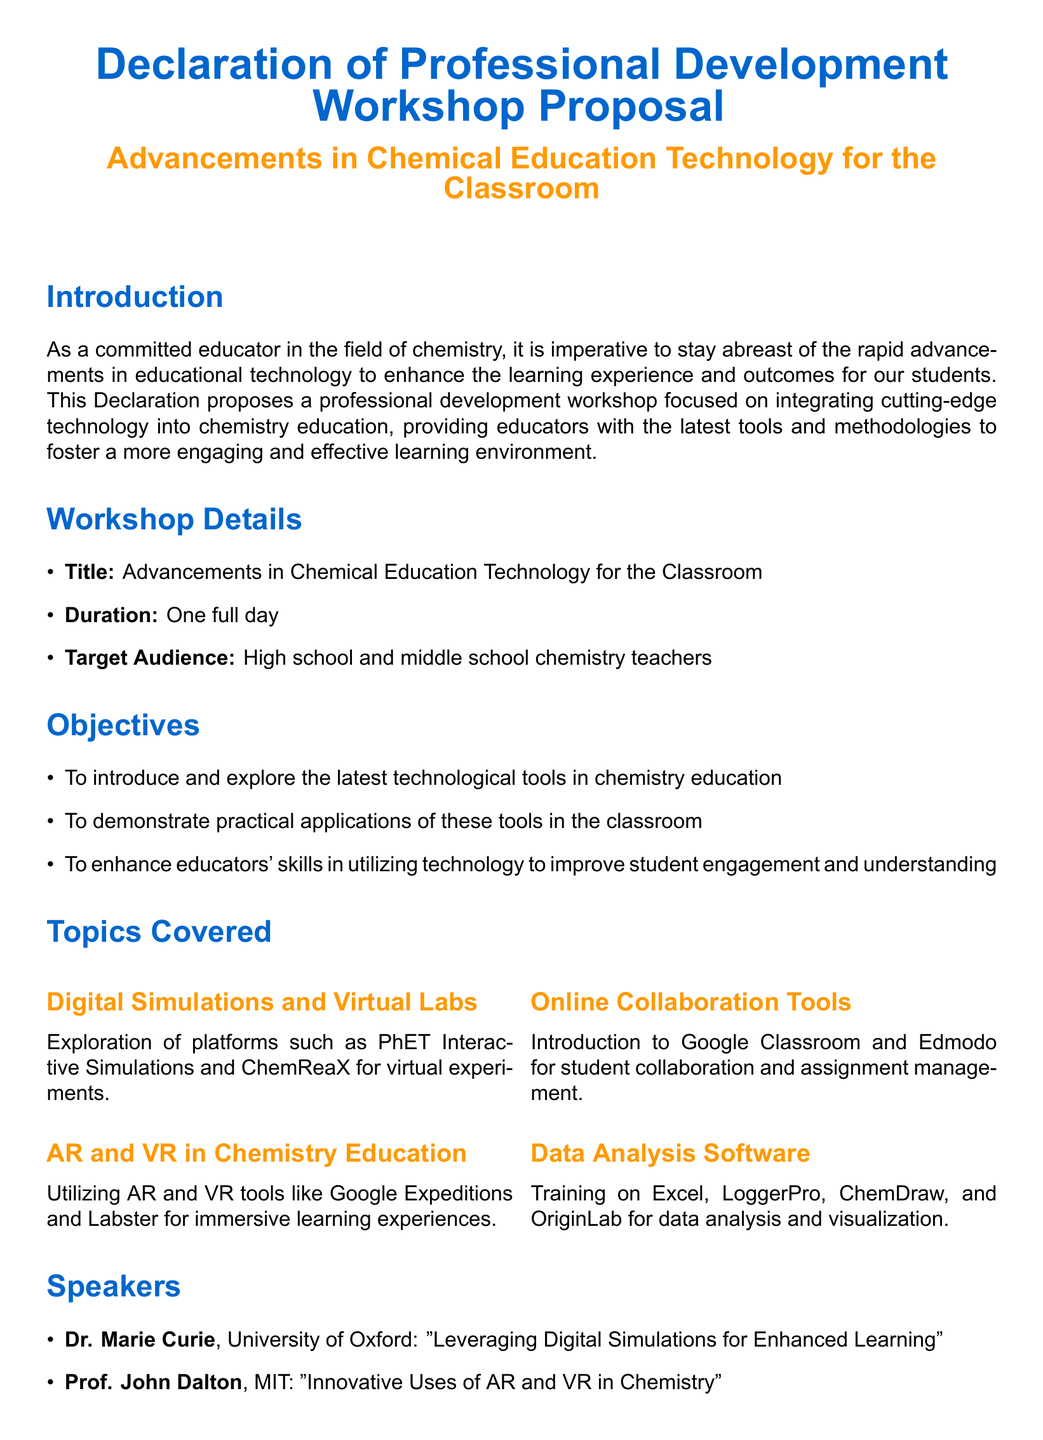What is the title of the workshop? The title of the workshop is stated clearly in the document under Workshop Details.
Answer: Advancements in Chemical Education Technology for the Classroom What is the duration of the workshop? The duration of the workshop is mentioned in the Workshop Details section.
Answer: One full day Who is the target audience for the workshop? The target audience is specified in the Workshop Details section.
Answer: High school and middle school chemistry teachers Which technology is used for digital simulations? The document lists platforms under Topics Covered, specifically in the Digital Simulations section.
Answer: PhET Interactive Simulations and ChemReaX Who is one of the speakers at the workshop? The document includes information about speakers in the Speakers section.
Answer: Dr. Marie Curie What is one expected outcome of the workshop? Expected outcomes are listed in the Expected Outcomes section of the document.
Answer: Increased proficiency in the use of technological tools in chemistry education Why is the workshop relevant to chemistry educators? The Introduction indicates the significance of the workshop for educators in the field.
Answer: To integrate cutting-edge technology into chemistry education What is the name of the online collaboration tool mentioned? Online collaboration tools are introduced under Topics Covered.
Answer: Google Classroom 